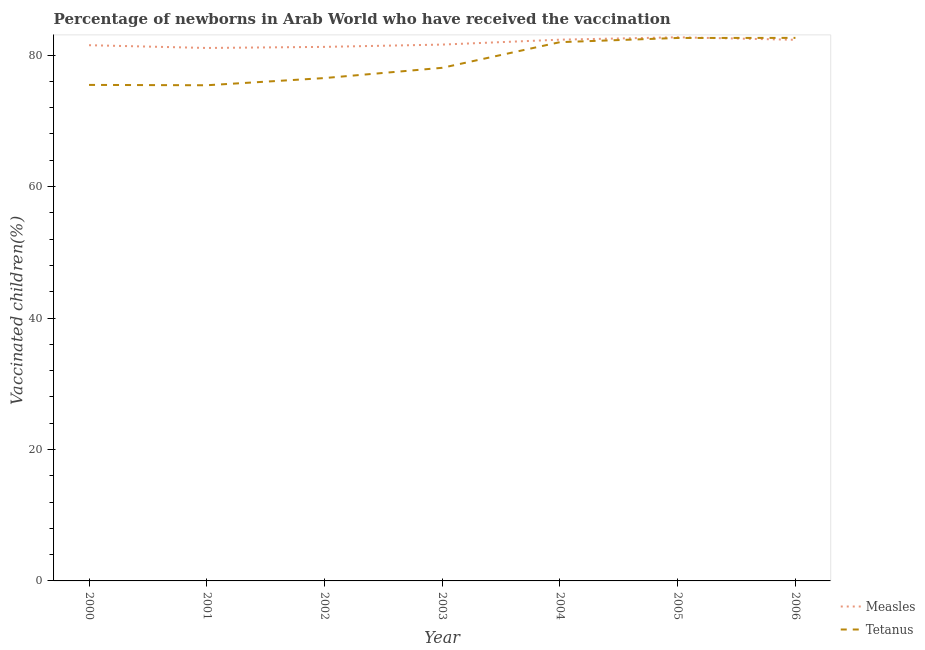How many different coloured lines are there?
Give a very brief answer. 2. What is the percentage of newborns who received vaccination for measles in 2001?
Offer a very short reply. 81.09. Across all years, what is the maximum percentage of newborns who received vaccination for tetanus?
Your answer should be compact. 82.62. Across all years, what is the minimum percentage of newborns who received vaccination for tetanus?
Give a very brief answer. 75.41. In which year was the percentage of newborns who received vaccination for measles maximum?
Offer a very short reply. 2005. What is the total percentage of newborns who received vaccination for tetanus in the graph?
Your response must be concise. 552.64. What is the difference between the percentage of newborns who received vaccination for tetanus in 2002 and that in 2006?
Provide a short and direct response. -6.11. What is the difference between the percentage of newborns who received vaccination for tetanus in 2006 and the percentage of newborns who received vaccination for measles in 2003?
Provide a succinct answer. 1.02. What is the average percentage of newborns who received vaccination for measles per year?
Offer a very short reply. 81.83. In the year 2002, what is the difference between the percentage of newborns who received vaccination for tetanus and percentage of newborns who received vaccination for measles?
Ensure brevity in your answer.  -4.74. What is the ratio of the percentage of newborns who received vaccination for measles in 2000 to that in 2003?
Give a very brief answer. 1. Is the percentage of newborns who received vaccination for measles in 2002 less than that in 2005?
Ensure brevity in your answer.  Yes. Is the difference between the percentage of newborns who received vaccination for measles in 2000 and 2006 greater than the difference between the percentage of newborns who received vaccination for tetanus in 2000 and 2006?
Provide a succinct answer. Yes. What is the difference between the highest and the second highest percentage of newborns who received vaccination for tetanus?
Keep it short and to the point. 0.01. What is the difference between the highest and the lowest percentage of newborns who received vaccination for measles?
Provide a short and direct response. 1.63. In how many years, is the percentage of newborns who received vaccination for tetanus greater than the average percentage of newborns who received vaccination for tetanus taken over all years?
Ensure brevity in your answer.  3. Does the percentage of newborns who received vaccination for tetanus monotonically increase over the years?
Make the answer very short. No. Is the percentage of newborns who received vaccination for tetanus strictly less than the percentage of newborns who received vaccination for measles over the years?
Your answer should be very brief. No. Are the values on the major ticks of Y-axis written in scientific E-notation?
Offer a very short reply. No. Does the graph contain any zero values?
Offer a very short reply. No. Where does the legend appear in the graph?
Provide a short and direct response. Bottom right. How are the legend labels stacked?
Make the answer very short. Vertical. What is the title of the graph?
Ensure brevity in your answer.  Percentage of newborns in Arab World who have received the vaccination. Does "Old" appear as one of the legend labels in the graph?
Ensure brevity in your answer.  No. What is the label or title of the Y-axis?
Keep it short and to the point. Vaccinated children(%)
. What is the Vaccinated children(%)
 of Measles in 2000?
Your answer should be compact. 81.51. What is the Vaccinated children(%)
 of Tetanus in 2000?
Provide a short and direct response. 75.46. What is the Vaccinated children(%)
 in Measles in 2001?
Offer a terse response. 81.09. What is the Vaccinated children(%)
 in Tetanus in 2001?
Your response must be concise. 75.41. What is the Vaccinated children(%)
 in Measles in 2002?
Provide a short and direct response. 81.25. What is the Vaccinated children(%)
 of Tetanus in 2002?
Keep it short and to the point. 76.51. What is the Vaccinated children(%)
 of Measles in 2003?
Keep it short and to the point. 81.6. What is the Vaccinated children(%)
 in Tetanus in 2003?
Your response must be concise. 78.07. What is the Vaccinated children(%)
 in Measles in 2004?
Provide a succinct answer. 82.35. What is the Vaccinated children(%)
 of Tetanus in 2004?
Provide a short and direct response. 81.97. What is the Vaccinated children(%)
 in Measles in 2005?
Offer a very short reply. 82.71. What is the Vaccinated children(%)
 in Tetanus in 2005?
Provide a succinct answer. 82.61. What is the Vaccinated children(%)
 in Measles in 2006?
Keep it short and to the point. 82.33. What is the Vaccinated children(%)
 of Tetanus in 2006?
Offer a very short reply. 82.62. Across all years, what is the maximum Vaccinated children(%)
 of Measles?
Your answer should be very brief. 82.71. Across all years, what is the maximum Vaccinated children(%)
 in Tetanus?
Your answer should be very brief. 82.62. Across all years, what is the minimum Vaccinated children(%)
 in Measles?
Offer a very short reply. 81.09. Across all years, what is the minimum Vaccinated children(%)
 of Tetanus?
Your answer should be very brief. 75.41. What is the total Vaccinated children(%)
 of Measles in the graph?
Your response must be concise. 572.83. What is the total Vaccinated children(%)
 of Tetanus in the graph?
Give a very brief answer. 552.64. What is the difference between the Vaccinated children(%)
 of Measles in 2000 and that in 2001?
Provide a succinct answer. 0.42. What is the difference between the Vaccinated children(%)
 of Tetanus in 2000 and that in 2001?
Make the answer very short. 0.05. What is the difference between the Vaccinated children(%)
 in Measles in 2000 and that in 2002?
Keep it short and to the point. 0.26. What is the difference between the Vaccinated children(%)
 in Tetanus in 2000 and that in 2002?
Your answer should be compact. -1.04. What is the difference between the Vaccinated children(%)
 of Measles in 2000 and that in 2003?
Ensure brevity in your answer.  -0.09. What is the difference between the Vaccinated children(%)
 of Tetanus in 2000 and that in 2003?
Offer a very short reply. -2.6. What is the difference between the Vaccinated children(%)
 of Measles in 2000 and that in 2004?
Your answer should be compact. -0.84. What is the difference between the Vaccinated children(%)
 in Tetanus in 2000 and that in 2004?
Your response must be concise. -6.51. What is the difference between the Vaccinated children(%)
 of Measles in 2000 and that in 2005?
Give a very brief answer. -1.21. What is the difference between the Vaccinated children(%)
 of Tetanus in 2000 and that in 2005?
Your response must be concise. -7.14. What is the difference between the Vaccinated children(%)
 in Measles in 2000 and that in 2006?
Provide a succinct answer. -0.82. What is the difference between the Vaccinated children(%)
 in Tetanus in 2000 and that in 2006?
Provide a succinct answer. -7.16. What is the difference between the Vaccinated children(%)
 in Measles in 2001 and that in 2002?
Provide a succinct answer. -0.17. What is the difference between the Vaccinated children(%)
 in Tetanus in 2001 and that in 2002?
Your response must be concise. -1.09. What is the difference between the Vaccinated children(%)
 of Measles in 2001 and that in 2003?
Provide a short and direct response. -0.51. What is the difference between the Vaccinated children(%)
 of Tetanus in 2001 and that in 2003?
Keep it short and to the point. -2.66. What is the difference between the Vaccinated children(%)
 of Measles in 2001 and that in 2004?
Provide a succinct answer. -1.26. What is the difference between the Vaccinated children(%)
 in Tetanus in 2001 and that in 2004?
Your response must be concise. -6.56. What is the difference between the Vaccinated children(%)
 in Measles in 2001 and that in 2005?
Your answer should be very brief. -1.63. What is the difference between the Vaccinated children(%)
 in Tetanus in 2001 and that in 2005?
Offer a terse response. -7.2. What is the difference between the Vaccinated children(%)
 in Measles in 2001 and that in 2006?
Your response must be concise. -1.24. What is the difference between the Vaccinated children(%)
 of Tetanus in 2001 and that in 2006?
Offer a very short reply. -7.21. What is the difference between the Vaccinated children(%)
 of Measles in 2002 and that in 2003?
Offer a very short reply. -0.35. What is the difference between the Vaccinated children(%)
 of Tetanus in 2002 and that in 2003?
Provide a short and direct response. -1.56. What is the difference between the Vaccinated children(%)
 of Measles in 2002 and that in 2004?
Provide a succinct answer. -1.1. What is the difference between the Vaccinated children(%)
 in Tetanus in 2002 and that in 2004?
Give a very brief answer. -5.46. What is the difference between the Vaccinated children(%)
 of Measles in 2002 and that in 2005?
Your response must be concise. -1.46. What is the difference between the Vaccinated children(%)
 of Tetanus in 2002 and that in 2005?
Your response must be concise. -6.1. What is the difference between the Vaccinated children(%)
 in Measles in 2002 and that in 2006?
Keep it short and to the point. -1.08. What is the difference between the Vaccinated children(%)
 of Tetanus in 2002 and that in 2006?
Your answer should be very brief. -6.11. What is the difference between the Vaccinated children(%)
 of Measles in 2003 and that in 2004?
Offer a terse response. -0.75. What is the difference between the Vaccinated children(%)
 in Tetanus in 2003 and that in 2004?
Your answer should be compact. -3.9. What is the difference between the Vaccinated children(%)
 of Measles in 2003 and that in 2005?
Provide a succinct answer. -1.11. What is the difference between the Vaccinated children(%)
 of Tetanus in 2003 and that in 2005?
Give a very brief answer. -4.54. What is the difference between the Vaccinated children(%)
 of Measles in 2003 and that in 2006?
Keep it short and to the point. -0.73. What is the difference between the Vaccinated children(%)
 in Tetanus in 2003 and that in 2006?
Keep it short and to the point. -4.55. What is the difference between the Vaccinated children(%)
 of Measles in 2004 and that in 2005?
Offer a terse response. -0.36. What is the difference between the Vaccinated children(%)
 in Tetanus in 2004 and that in 2005?
Your response must be concise. -0.64. What is the difference between the Vaccinated children(%)
 in Measles in 2004 and that in 2006?
Ensure brevity in your answer.  0.02. What is the difference between the Vaccinated children(%)
 of Tetanus in 2004 and that in 2006?
Your answer should be compact. -0.65. What is the difference between the Vaccinated children(%)
 in Measles in 2005 and that in 2006?
Provide a succinct answer. 0.38. What is the difference between the Vaccinated children(%)
 of Tetanus in 2005 and that in 2006?
Ensure brevity in your answer.  -0.01. What is the difference between the Vaccinated children(%)
 in Measles in 2000 and the Vaccinated children(%)
 in Tetanus in 2001?
Your answer should be very brief. 6.09. What is the difference between the Vaccinated children(%)
 in Measles in 2000 and the Vaccinated children(%)
 in Tetanus in 2002?
Your answer should be compact. 5. What is the difference between the Vaccinated children(%)
 of Measles in 2000 and the Vaccinated children(%)
 of Tetanus in 2003?
Provide a succinct answer. 3.44. What is the difference between the Vaccinated children(%)
 of Measles in 2000 and the Vaccinated children(%)
 of Tetanus in 2004?
Make the answer very short. -0.46. What is the difference between the Vaccinated children(%)
 in Measles in 2000 and the Vaccinated children(%)
 in Tetanus in 2005?
Offer a very short reply. -1.1. What is the difference between the Vaccinated children(%)
 of Measles in 2000 and the Vaccinated children(%)
 of Tetanus in 2006?
Offer a terse response. -1.11. What is the difference between the Vaccinated children(%)
 of Measles in 2001 and the Vaccinated children(%)
 of Tetanus in 2002?
Keep it short and to the point. 4.58. What is the difference between the Vaccinated children(%)
 of Measles in 2001 and the Vaccinated children(%)
 of Tetanus in 2003?
Keep it short and to the point. 3.02. What is the difference between the Vaccinated children(%)
 of Measles in 2001 and the Vaccinated children(%)
 of Tetanus in 2004?
Your response must be concise. -0.88. What is the difference between the Vaccinated children(%)
 in Measles in 2001 and the Vaccinated children(%)
 in Tetanus in 2005?
Ensure brevity in your answer.  -1.52. What is the difference between the Vaccinated children(%)
 in Measles in 2001 and the Vaccinated children(%)
 in Tetanus in 2006?
Make the answer very short. -1.53. What is the difference between the Vaccinated children(%)
 of Measles in 2002 and the Vaccinated children(%)
 of Tetanus in 2003?
Offer a terse response. 3.18. What is the difference between the Vaccinated children(%)
 in Measles in 2002 and the Vaccinated children(%)
 in Tetanus in 2004?
Make the answer very short. -0.72. What is the difference between the Vaccinated children(%)
 in Measles in 2002 and the Vaccinated children(%)
 in Tetanus in 2005?
Offer a very short reply. -1.36. What is the difference between the Vaccinated children(%)
 in Measles in 2002 and the Vaccinated children(%)
 in Tetanus in 2006?
Give a very brief answer. -1.37. What is the difference between the Vaccinated children(%)
 of Measles in 2003 and the Vaccinated children(%)
 of Tetanus in 2004?
Your answer should be very brief. -0.37. What is the difference between the Vaccinated children(%)
 of Measles in 2003 and the Vaccinated children(%)
 of Tetanus in 2005?
Your response must be concise. -1.01. What is the difference between the Vaccinated children(%)
 in Measles in 2003 and the Vaccinated children(%)
 in Tetanus in 2006?
Keep it short and to the point. -1.02. What is the difference between the Vaccinated children(%)
 in Measles in 2004 and the Vaccinated children(%)
 in Tetanus in 2005?
Make the answer very short. -0.26. What is the difference between the Vaccinated children(%)
 of Measles in 2004 and the Vaccinated children(%)
 of Tetanus in 2006?
Your answer should be very brief. -0.27. What is the difference between the Vaccinated children(%)
 in Measles in 2005 and the Vaccinated children(%)
 in Tetanus in 2006?
Keep it short and to the point. 0.09. What is the average Vaccinated children(%)
 in Measles per year?
Make the answer very short. 81.83. What is the average Vaccinated children(%)
 in Tetanus per year?
Your response must be concise. 78.95. In the year 2000, what is the difference between the Vaccinated children(%)
 of Measles and Vaccinated children(%)
 of Tetanus?
Give a very brief answer. 6.04. In the year 2001, what is the difference between the Vaccinated children(%)
 in Measles and Vaccinated children(%)
 in Tetanus?
Offer a very short reply. 5.67. In the year 2002, what is the difference between the Vaccinated children(%)
 of Measles and Vaccinated children(%)
 of Tetanus?
Your response must be concise. 4.74. In the year 2003, what is the difference between the Vaccinated children(%)
 of Measles and Vaccinated children(%)
 of Tetanus?
Offer a terse response. 3.53. In the year 2004, what is the difference between the Vaccinated children(%)
 of Measles and Vaccinated children(%)
 of Tetanus?
Keep it short and to the point. 0.38. In the year 2005, what is the difference between the Vaccinated children(%)
 of Measles and Vaccinated children(%)
 of Tetanus?
Provide a short and direct response. 0.1. In the year 2006, what is the difference between the Vaccinated children(%)
 in Measles and Vaccinated children(%)
 in Tetanus?
Keep it short and to the point. -0.29. What is the ratio of the Vaccinated children(%)
 of Measles in 2000 to that in 2001?
Make the answer very short. 1.01. What is the ratio of the Vaccinated children(%)
 in Tetanus in 2000 to that in 2001?
Provide a short and direct response. 1. What is the ratio of the Vaccinated children(%)
 of Measles in 2000 to that in 2002?
Your response must be concise. 1. What is the ratio of the Vaccinated children(%)
 in Tetanus in 2000 to that in 2002?
Make the answer very short. 0.99. What is the ratio of the Vaccinated children(%)
 in Measles in 2000 to that in 2003?
Provide a short and direct response. 1. What is the ratio of the Vaccinated children(%)
 in Tetanus in 2000 to that in 2003?
Keep it short and to the point. 0.97. What is the ratio of the Vaccinated children(%)
 in Measles in 2000 to that in 2004?
Provide a short and direct response. 0.99. What is the ratio of the Vaccinated children(%)
 in Tetanus in 2000 to that in 2004?
Offer a terse response. 0.92. What is the ratio of the Vaccinated children(%)
 in Measles in 2000 to that in 2005?
Ensure brevity in your answer.  0.99. What is the ratio of the Vaccinated children(%)
 in Tetanus in 2000 to that in 2005?
Keep it short and to the point. 0.91. What is the ratio of the Vaccinated children(%)
 in Measles in 2000 to that in 2006?
Keep it short and to the point. 0.99. What is the ratio of the Vaccinated children(%)
 in Tetanus in 2000 to that in 2006?
Provide a succinct answer. 0.91. What is the ratio of the Vaccinated children(%)
 in Measles in 2001 to that in 2002?
Offer a very short reply. 1. What is the ratio of the Vaccinated children(%)
 in Tetanus in 2001 to that in 2002?
Your answer should be compact. 0.99. What is the ratio of the Vaccinated children(%)
 of Measles in 2001 to that in 2004?
Make the answer very short. 0.98. What is the ratio of the Vaccinated children(%)
 of Tetanus in 2001 to that in 2004?
Your answer should be compact. 0.92. What is the ratio of the Vaccinated children(%)
 of Measles in 2001 to that in 2005?
Provide a succinct answer. 0.98. What is the ratio of the Vaccinated children(%)
 in Tetanus in 2001 to that in 2005?
Make the answer very short. 0.91. What is the ratio of the Vaccinated children(%)
 of Measles in 2001 to that in 2006?
Ensure brevity in your answer.  0.98. What is the ratio of the Vaccinated children(%)
 of Tetanus in 2001 to that in 2006?
Your answer should be compact. 0.91. What is the ratio of the Vaccinated children(%)
 of Measles in 2002 to that in 2003?
Your answer should be very brief. 1. What is the ratio of the Vaccinated children(%)
 of Tetanus in 2002 to that in 2003?
Provide a short and direct response. 0.98. What is the ratio of the Vaccinated children(%)
 of Measles in 2002 to that in 2004?
Provide a succinct answer. 0.99. What is the ratio of the Vaccinated children(%)
 of Measles in 2002 to that in 2005?
Your answer should be very brief. 0.98. What is the ratio of the Vaccinated children(%)
 in Tetanus in 2002 to that in 2005?
Offer a very short reply. 0.93. What is the ratio of the Vaccinated children(%)
 of Measles in 2002 to that in 2006?
Provide a succinct answer. 0.99. What is the ratio of the Vaccinated children(%)
 in Tetanus in 2002 to that in 2006?
Provide a succinct answer. 0.93. What is the ratio of the Vaccinated children(%)
 in Measles in 2003 to that in 2004?
Provide a succinct answer. 0.99. What is the ratio of the Vaccinated children(%)
 of Tetanus in 2003 to that in 2004?
Keep it short and to the point. 0.95. What is the ratio of the Vaccinated children(%)
 of Measles in 2003 to that in 2005?
Your answer should be compact. 0.99. What is the ratio of the Vaccinated children(%)
 in Tetanus in 2003 to that in 2005?
Make the answer very short. 0.94. What is the ratio of the Vaccinated children(%)
 of Measles in 2003 to that in 2006?
Offer a terse response. 0.99. What is the ratio of the Vaccinated children(%)
 of Tetanus in 2003 to that in 2006?
Give a very brief answer. 0.94. What is the ratio of the Vaccinated children(%)
 of Tetanus in 2004 to that in 2005?
Ensure brevity in your answer.  0.99. What is the ratio of the Vaccinated children(%)
 of Measles in 2004 to that in 2006?
Your response must be concise. 1. What is the difference between the highest and the second highest Vaccinated children(%)
 of Measles?
Your response must be concise. 0.36. What is the difference between the highest and the second highest Vaccinated children(%)
 of Tetanus?
Ensure brevity in your answer.  0.01. What is the difference between the highest and the lowest Vaccinated children(%)
 of Measles?
Offer a terse response. 1.63. What is the difference between the highest and the lowest Vaccinated children(%)
 of Tetanus?
Keep it short and to the point. 7.21. 